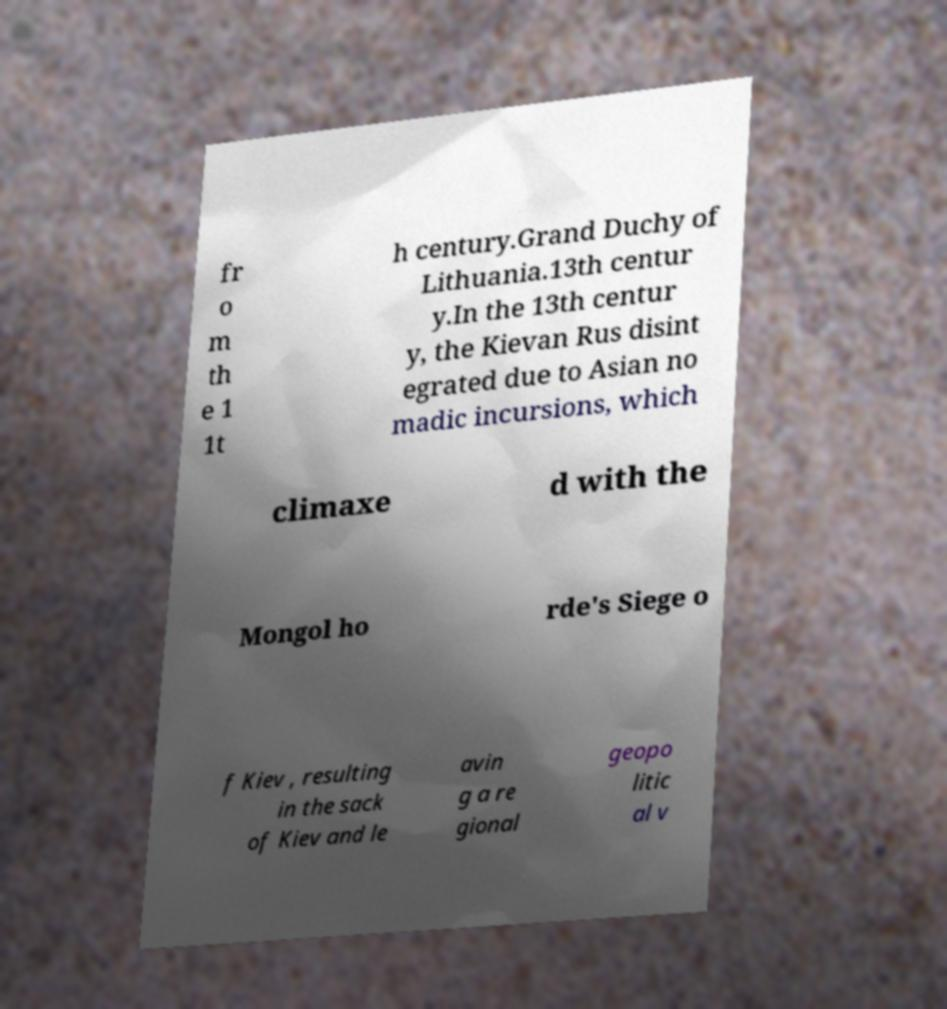Please identify and transcribe the text found in this image. fr o m th e 1 1t h century.Grand Duchy of Lithuania.13th centur y.In the 13th centur y, the Kievan Rus disint egrated due to Asian no madic incursions, which climaxe d with the Mongol ho rde's Siege o f Kiev , resulting in the sack of Kiev and le avin g a re gional geopo litic al v 